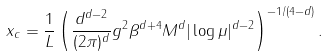<formula> <loc_0><loc_0><loc_500><loc_500>x _ { c } = \frac { 1 } { L } \left ( \frac { d ^ { d - 2 } } { ( 2 \pi ) ^ { d } } g ^ { 2 } \beta ^ { d + 4 } M ^ { d } | \log \mu | ^ { d - 2 } \right ) ^ { - 1 / ( 4 - d ) } .</formula> 